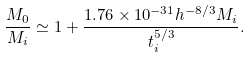Convert formula to latex. <formula><loc_0><loc_0><loc_500><loc_500>\frac { M _ { 0 } } { M _ { i } } \simeq 1 + \frac { 1 . 7 6 \times 1 0 ^ { - 3 1 } h ^ { - 8 / 3 } M _ { i } } { t _ { i } ^ { 5 / 3 } } .</formula> 